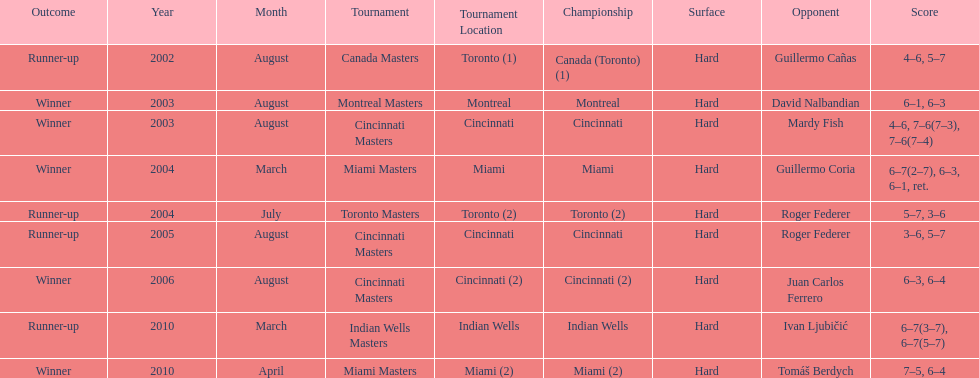How many consecutive years was there a hard surface at the championship? 9. 